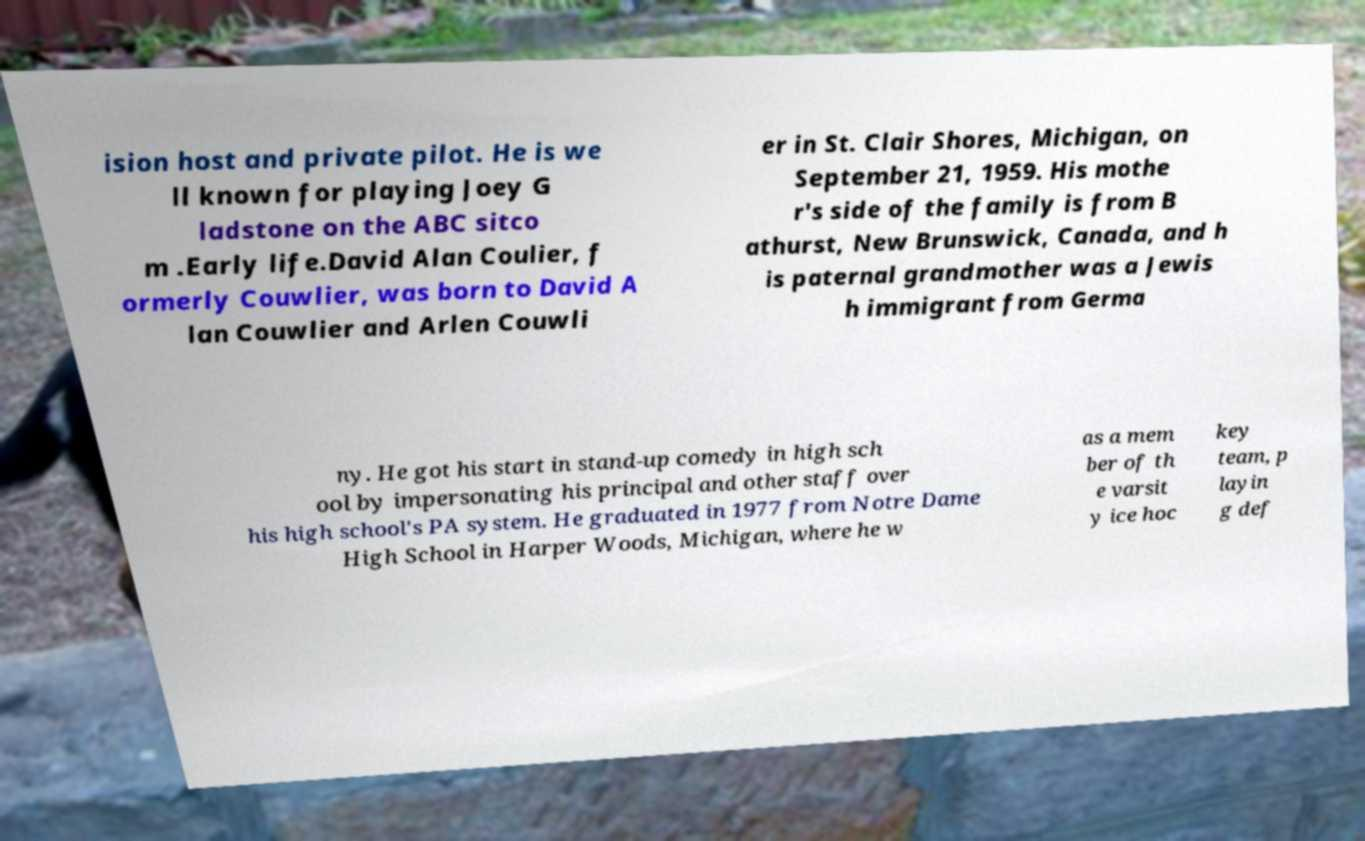Can you read and provide the text displayed in the image?This photo seems to have some interesting text. Can you extract and type it out for me? ision host and private pilot. He is we ll known for playing Joey G ladstone on the ABC sitco m .Early life.David Alan Coulier, f ormerly Couwlier, was born to David A lan Couwlier and Arlen Couwli er in St. Clair Shores, Michigan, on September 21, 1959. His mothe r's side of the family is from B athurst, New Brunswick, Canada, and h is paternal grandmother was a Jewis h immigrant from Germa ny. He got his start in stand-up comedy in high sch ool by impersonating his principal and other staff over his high school's PA system. He graduated in 1977 from Notre Dame High School in Harper Woods, Michigan, where he w as a mem ber of th e varsit y ice hoc key team, p layin g def 